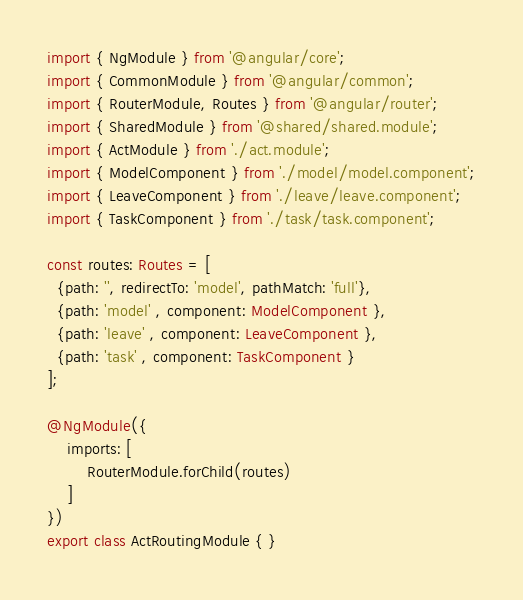Convert code to text. <code><loc_0><loc_0><loc_500><loc_500><_TypeScript_>import { NgModule } from '@angular/core';
import { CommonModule } from '@angular/common';
import { RouterModule, Routes } from '@angular/router';
import { SharedModule } from '@shared/shared.module';
import { ActModule } from './act.module';
import { ModelComponent } from './model/model.component';
import { LeaveComponent } from './leave/leave.component';
import { TaskComponent } from './task/task.component';

const routes: Routes = [
  {path: '', redirectTo: 'model', pathMatch: 'full'},
  {path: 'model' , component: ModelComponent },
  {path: 'leave' , component: LeaveComponent },
  {path: 'task' , component: TaskComponent }
];

@NgModule({
    imports: [
        RouterModule.forChild(routes)
    ]
})
export class ActRoutingModule { }
</code> 